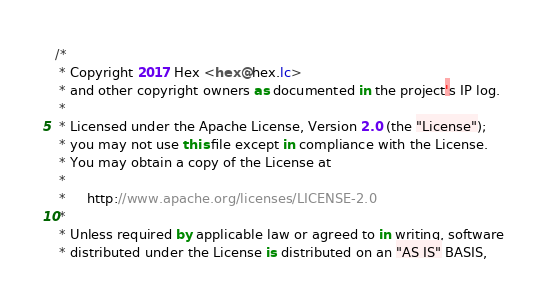Convert code to text. <code><loc_0><loc_0><loc_500><loc_500><_Kotlin_>/*
 * Copyright 2017 Hex <hex@hex.lc>
 * and other copyright owners as documented in the project's IP log.
 *
 * Licensed under the Apache License, Version 2.0 (the "License");
 * you may not use this file except in compliance with the License.
 * You may obtain a copy of the License at
 *
 *     http://www.apache.org/licenses/LICENSE-2.0
 *
 * Unless required by applicable law or agreed to in writing, software
 * distributed under the License is distributed on an "AS IS" BASIS,</code> 